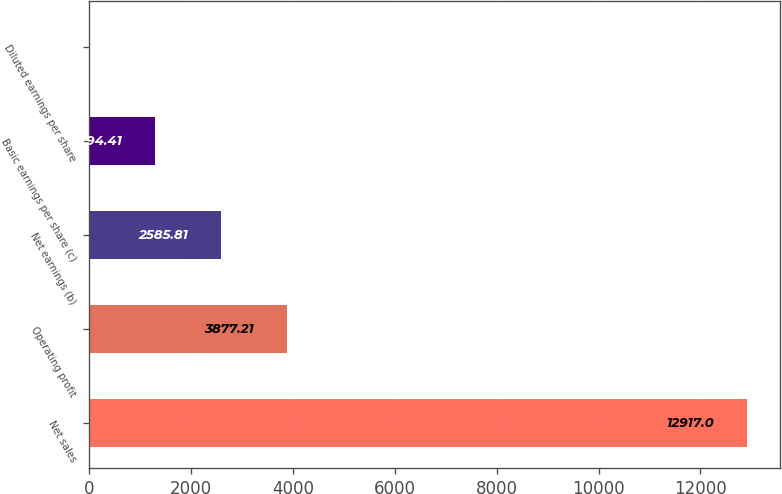<chart> <loc_0><loc_0><loc_500><loc_500><bar_chart><fcel>Net sales<fcel>Operating profit<fcel>Net earnings (b)<fcel>Basic earnings per share (c)<fcel>Diluted earnings per share<nl><fcel>12917<fcel>3877.21<fcel>2585.81<fcel>1294.41<fcel>3.01<nl></chart> 